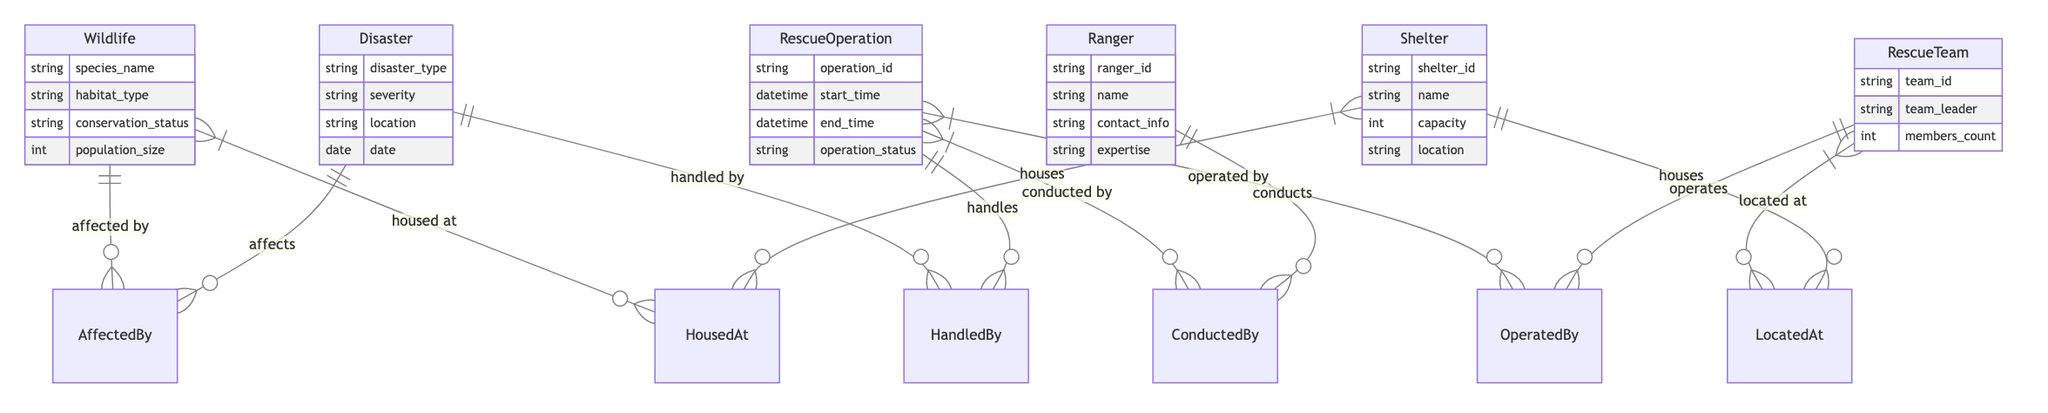What attributes are included in the Wildlife entity? The Wildlife entity has attributes: species_name, habitat_type, conservation_status, and population_size. This information can be extracted directly from the diagram, where the attributes are listed under the Wildlife entity.
Answer: species_name, habitat_type, conservation_status, population_size How many relationships are present in the diagram? The diagram has a total of six relationships connecting various entities. By counting each labeled relationship line between entities, we can determine the total number of connections in the diagram.
Answer: 6 What type of relationship connects Wildlife and Disaster? The relationship between Wildlife and Disaster is named "AffectedBy." This is indicated on the diagram through the labeling associated with the connecting line between the Wildlife and Disaster entities.
Answer: AffectedBy Which entity contains the attribute 'capacity'? The Shelter entity contains the attribute 'capacity.' This attribute is found in the list of attributes directly connected to the Shelter entity in the diagram.
Answer: Shelter How many attributes does the RescueTeam entity have? The RescueTeam entity has three attributes: team_id, team_leader, and members_count. These attributes are directly listed under the RescueTeam entity in the diagram.
Answer: 3 Which entities relate to the operation status of RescueOperation? The RescueOperation entity is related to the Ranger entity through the "ConductedBy" relationship, and it is connected to the RescueTeam entity through the "OperatedBy" relationship. Both relationships influence the operation status indirectly, as they involve different entities conducting and operating the rescue operation.
Answer: Ranger, RescueTeam How many entities are affected by a Disaster? Based on the diagram, the Disaster entity affects Wildlife, indicating at least one entity affected by a disaster, though multiple wildlife species could potentially be impacted, but the diagram explicitly states only the connection to Wildlife.
Answer: 1 What is the relationship between RescueOperation and Ranger? The relationship between RescueOperation and Ranger is named "ConductedBy." This is denoted by the connecting line and labeling in the Entity Relationship Diagram, showcasing how RescueOperations are conducted by Rangers.
Answer: ConductedBy Where are RescueTeams located? RescueTeams are located at Shelters, as indicated by the "LocatedAt" relationship connecting the RescueTeam and Shelter entities in the diagram.
Answer: Shelters 